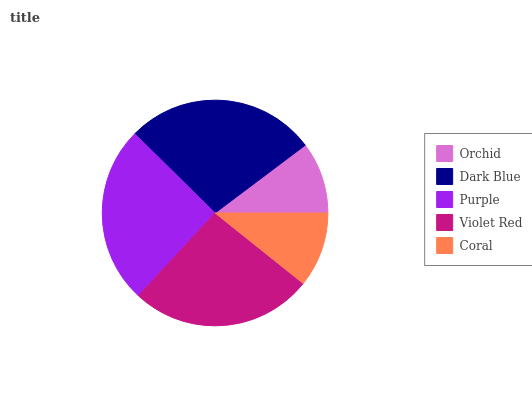Is Orchid the minimum?
Answer yes or no. Yes. Is Dark Blue the maximum?
Answer yes or no. Yes. Is Purple the minimum?
Answer yes or no. No. Is Purple the maximum?
Answer yes or no. No. Is Dark Blue greater than Purple?
Answer yes or no. Yes. Is Purple less than Dark Blue?
Answer yes or no. Yes. Is Purple greater than Dark Blue?
Answer yes or no. No. Is Dark Blue less than Purple?
Answer yes or no. No. Is Purple the high median?
Answer yes or no. Yes. Is Purple the low median?
Answer yes or no. Yes. Is Violet Red the high median?
Answer yes or no. No. Is Orchid the low median?
Answer yes or no. No. 